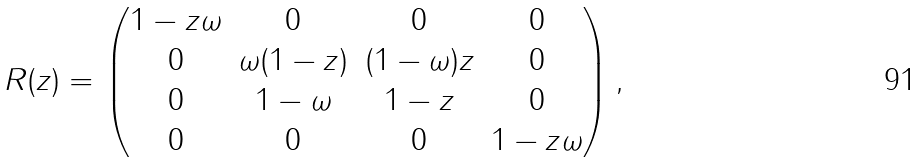Convert formula to latex. <formula><loc_0><loc_0><loc_500><loc_500>R ( z ) = \begin{pmatrix} 1 - z \omega & 0 & 0 & 0 \\ 0 & \omega ( 1 - z ) & ( 1 - \omega ) z & 0 \\ 0 & 1 - \omega & 1 - z & 0 \\ 0 & 0 & 0 & 1 - z \omega \\ \end{pmatrix} ,</formula> 